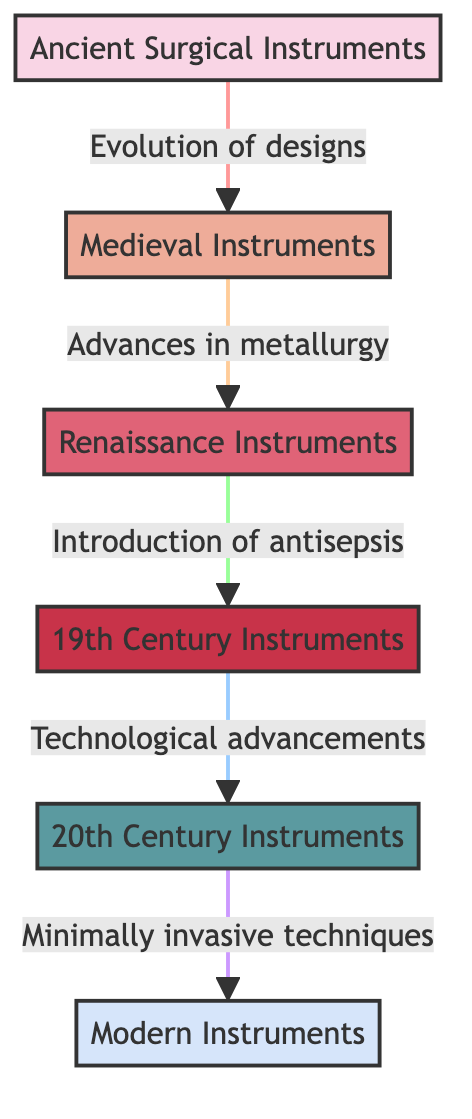What is the first type of surgical instruments mentioned in the diagram? The diagram lists "Ancient Surgical Instruments" as the first type at the top, indicating that it's the starting point of the evolution depicted.
Answer: Ancient Surgical Instruments Which type of instruments evolve from Medieval Instruments? The diagram shows an arrow from "Medieval Instruments" to "Renaissance Instruments," indicating that Renaissance Instruments are a subsequent evolution.
Answer: Renaissance Instruments How many main types of surgical instruments are represented in the flowchart? By counting the nodes in the diagram, there are six distinct types of instruments mentioned from ancient to modern times.
Answer: Six What advancement is introduced after Renaissance Instruments? The flowchart indicates that "Introduction of antisepsis" is the key advancement that follows after "Renaissance Instruments."
Answer: Introduction of antisepsis What is the relationship between 19th Century Instruments and 20th Century Instruments? The diagram illustrates that "Technological advancements" occur between 19th Century Instruments and 20th Century Instruments, showing a causal relationship of progress.
Answer: Technological advancements What color represents Modern Instruments in the diagram? The node representing "Modern Instruments" is filled with a light blue color, specifically labeled as "#d6e5fa."
Answer: Light blue What are the two types of advancements highlighted between Medieval and Renaissance Instruments? Between "Medieval Instruments" and "Renaissance Instruments," the diagram specifies "Advances in metallurgy" as the type of evolution, emphasizing technological progress.
Answer: Advances in metallurgy How does the evolution process transition from the 20th Century to Modern Instruments? The diagram indicates a transition through the application of "Minimally invasive techniques" leading to the modern surgical tools used today, representing a significant change in practice.
Answer: Minimally invasive techniques What type of diagram is shown to represent the timeline of surgical instruments? The diagram is a flowchart, which visually depicts the sequential evolution and relationships between different historical types of surgical instruments.
Answer: Flowchart What color is used for the Ancient surgical instruments? The node for "Ancient Surgical Instruments" is filled in a pink hue, defined as "#f9d5e5" within the diagram.
Answer: Pink 